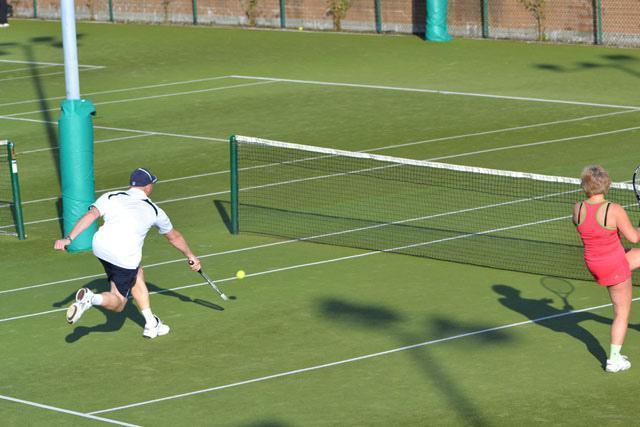How many people are visible?
Give a very brief answer. 2. 